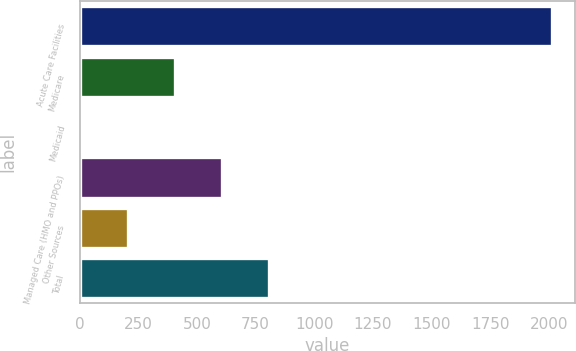<chart> <loc_0><loc_0><loc_500><loc_500><bar_chart><fcel>Acute Care Facilities<fcel>Medicare<fcel>Medicaid<fcel>Managed Care (HMO and PPOs)<fcel>Other Sources<fcel>Total<nl><fcel>2012<fcel>408<fcel>7<fcel>608.5<fcel>207.5<fcel>809<nl></chart> 